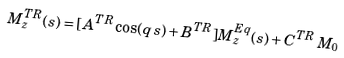<formula> <loc_0><loc_0><loc_500><loc_500>M _ { z } ^ { T R } ( s ) = [ A ^ { T R } \cos ( q \, s ) + B ^ { T R } ] M _ { z } ^ { E q } ( s ) + C ^ { T R } \, M _ { 0 }</formula> 